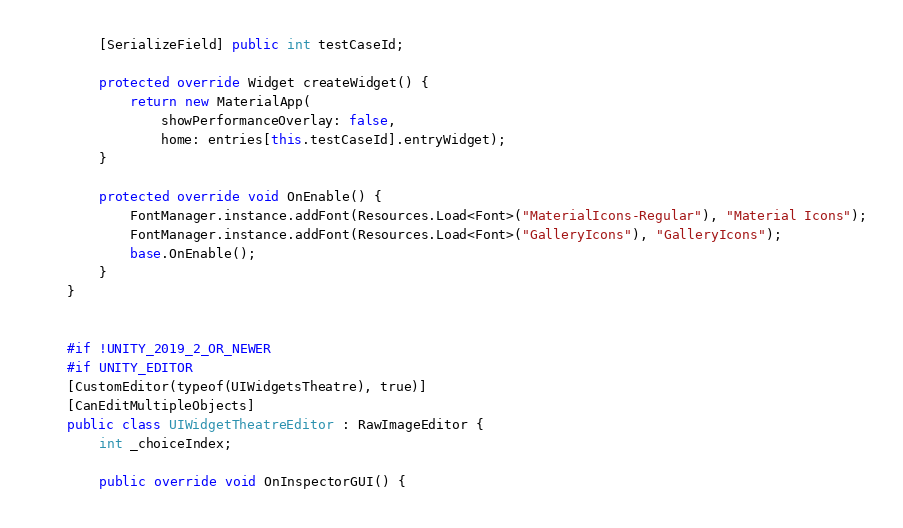Convert code to text. <code><loc_0><loc_0><loc_500><loc_500><_C#_>        [SerializeField] public int testCaseId;

        protected override Widget createWidget() {
            return new MaterialApp(
                showPerformanceOverlay: false,
                home: entries[this.testCaseId].entryWidget);
        }

        protected override void OnEnable() {
            FontManager.instance.addFont(Resources.Load<Font>("MaterialIcons-Regular"), "Material Icons");
            FontManager.instance.addFont(Resources.Load<Font>("GalleryIcons"), "GalleryIcons");
            base.OnEnable();
        }
    }
    
    
    #if !UNITY_2019_2_OR_NEWER
    #if UNITY_EDITOR
    [CustomEditor(typeof(UIWidgetsTheatre), true)]
    [CanEditMultipleObjects]
    public class UIWidgetTheatreEditor : RawImageEditor {
        int _choiceIndex;
        
        public override void OnInspectorGUI() {</code> 